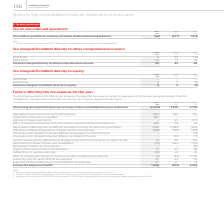From Vodafone Group Plc's financial document, Which financial years' information is shown in the table? The document contains multiple relevant values: 2017, 2018, 2019. From the document: "2019 2018 2017 €m €m €m Tax credit on profit from ordinary activities of discontinued operations 1 (56) (617) (973 138 Vodafone Group Plc Annual Repor..." Also, What does the table explain? the differences between the expected tax expense, being the aggregate of the Group’s geographical split of profits multiplied by the relevant local tax rates and the Group’s total tax expense for each year. The document states: "tax expense for the year The table below explains the differences between the expected tax expense, being the aggregate of the Group’s geographical sp..." Also, How much is the 2018 aggregated expected income expense ? According to the financial document, 985 (in millions). The relevant text states: "egated expected income tax (credit)/expense (457) 985 795 Impairment losses with no tax effect 807 – – Disposal of Group investments – 55 (271) Effect of..." Also, can you calculate: What is the 2018 deferred tax on overseas earnings, excluding the 15€m charge relating to the combination of Vodafone India with Idea Cellular? Based on the calculation: 24-15, the result is 9 (in millions). This is based on the information: "79 93 98 Deferred tax on overseas earnings 3 (39) 24 26 Effect of current year changes in statutory tax rates on deferred tax balances (2) (44) 2,755 Fi y differences we expect to use in the future – ..." The key data points involved are: 15, 24. Also, can you calculate: What is the 2017 deferred tax on overseas earnings, excluding the 95€m charge relating to the combination of Vodafone India with Idea Cellular? Based on the calculation: 26-95, the result is -69 (in millions). This is based on the information: "93 98 Deferred tax on overseas earnings 3 (39) 24 26 Effect of current year changes in statutory tax rates on deferred tax balances (2) (44) 2,755 Finan d expected income tax (credit)/expense (457) 98..." The key data points involved are: 26, 95. Also, can you calculate: What is the change between 2017-2018 and 2018-2019 average income tax expense? To answer this question, I need to perform calculations using the financial data. The calculation is: [1,496 +(-879)]/ 2 - [(-879)+ 4,764]/ 2, which equals -1634 (in millions). This is based on the information: "tax purposes 97 61 72 Income tax expense/(credit) 1,496 (879) 4,764 poses 97 61 72 Income tax expense/(credit) 1,496 (879) 4,764 tax purposes 97 61 72 Income tax expense/(credit) 1,496 (879) 4,764 97 ..." The key data points involved are: 1,496, 2, 4,764. 